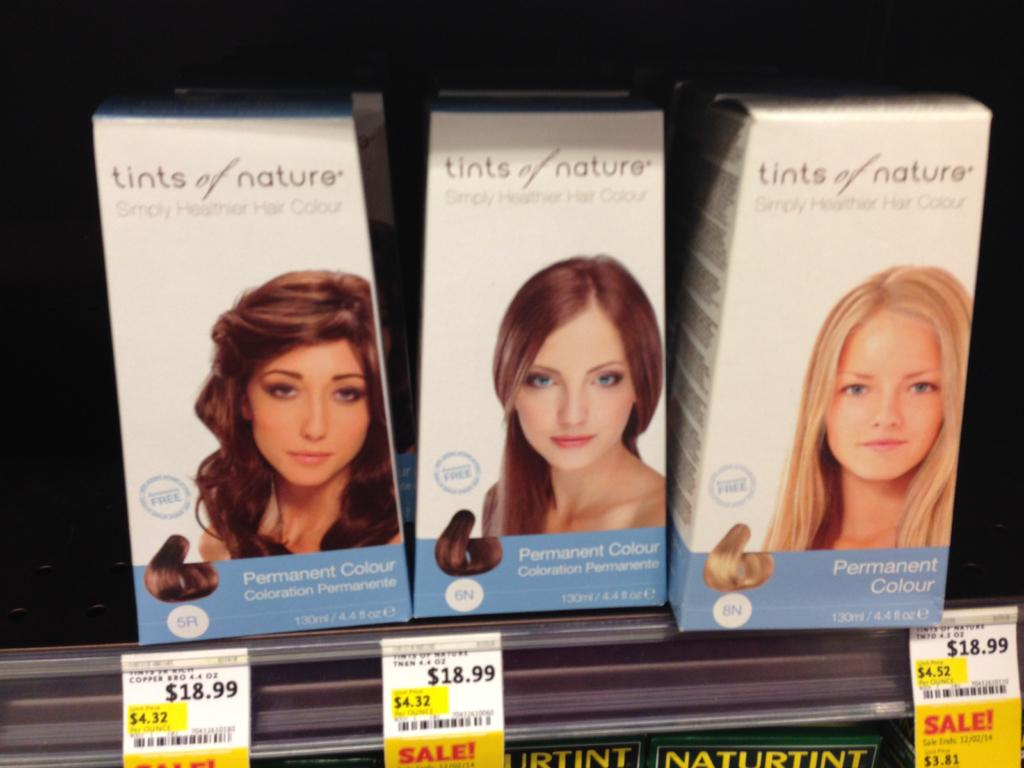What objects are visible in the image? There are boxes in the image. Where are the boxes located? The boxes are in a rack. Are there any additional details about the boxes or their arrangement? Price tags are present in the image. What type of land can be seen in the image? There is no land visible in the image; it features boxes in a rack with price tags. 